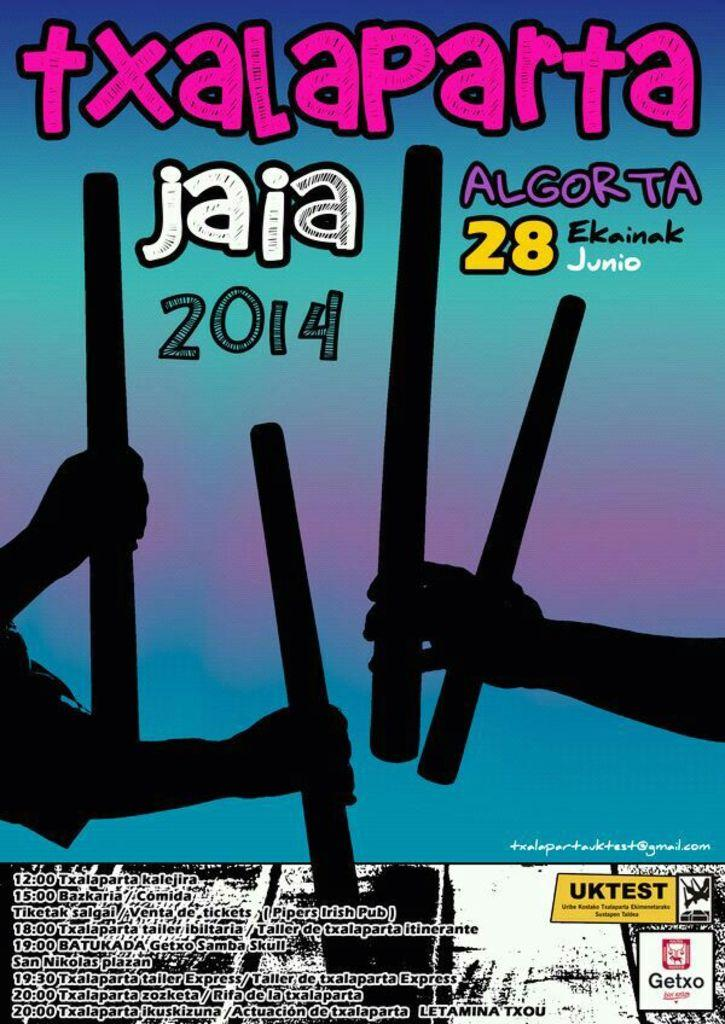<image>
Share a concise interpretation of the image provided. txalaparta jaia algorta 2014 paper with times at the bottom 